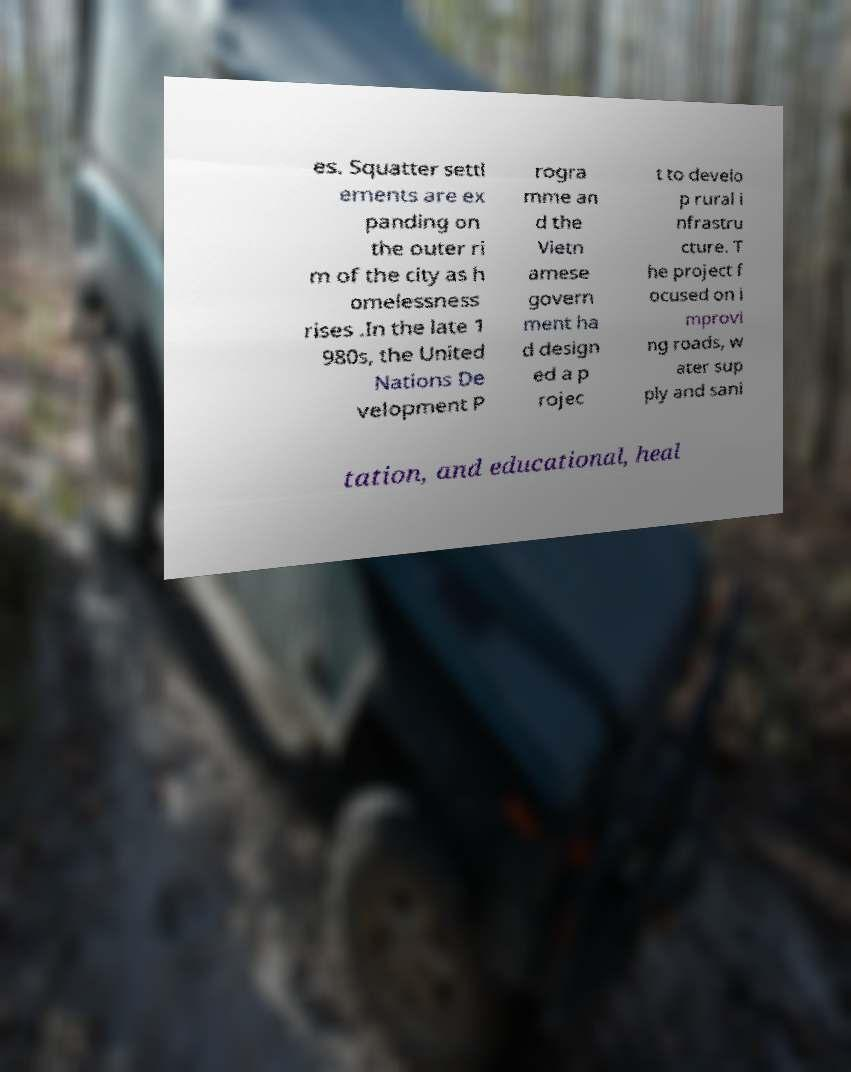Please read and relay the text visible in this image. What does it say? es. Squatter settl ements are ex panding on the outer ri m of the city as h omelessness rises .In the late 1 980s, the United Nations De velopment P rogra mme an d the Vietn amese govern ment ha d design ed a p rojec t to develo p rural i nfrastru cture. T he project f ocused on i mprovi ng roads, w ater sup ply and sani tation, and educational, heal 